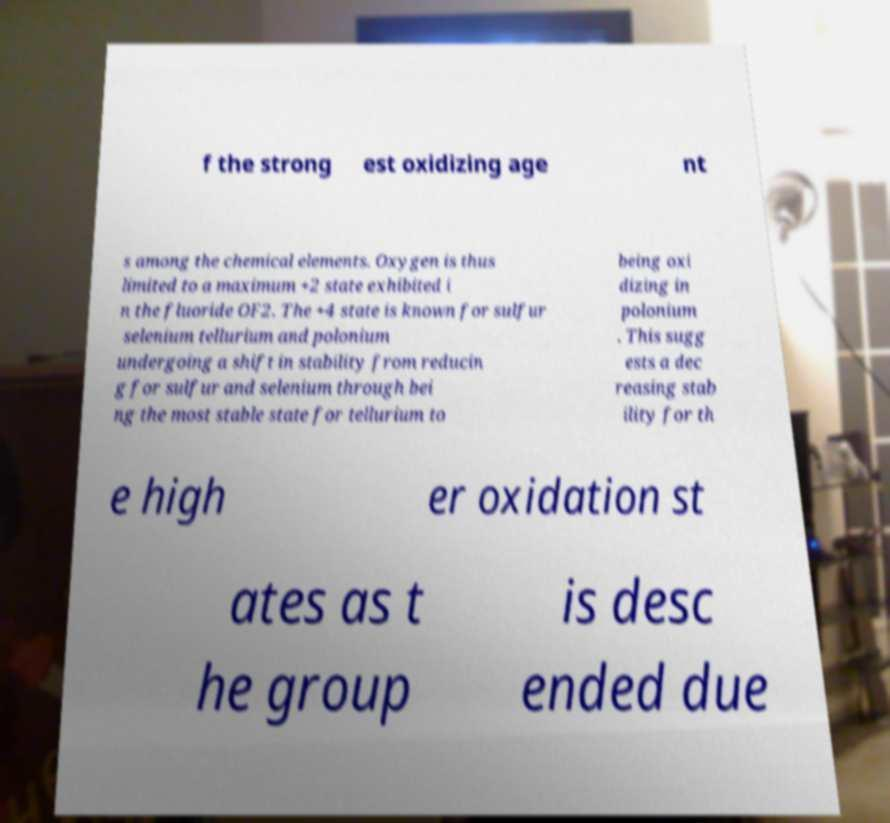What messages or text are displayed in this image? I need them in a readable, typed format. f the strong est oxidizing age nt s among the chemical elements. Oxygen is thus limited to a maximum +2 state exhibited i n the fluoride OF2. The +4 state is known for sulfur selenium tellurium and polonium undergoing a shift in stability from reducin g for sulfur and selenium through bei ng the most stable state for tellurium to being oxi dizing in polonium . This sugg ests a dec reasing stab ility for th e high er oxidation st ates as t he group is desc ended due 